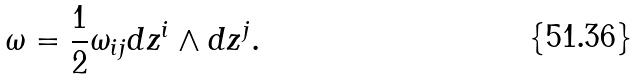<formula> <loc_0><loc_0><loc_500><loc_500>\omega = \frac { 1 } { 2 } \omega _ { i j } d z ^ { i } \wedge d z ^ { j } .</formula> 